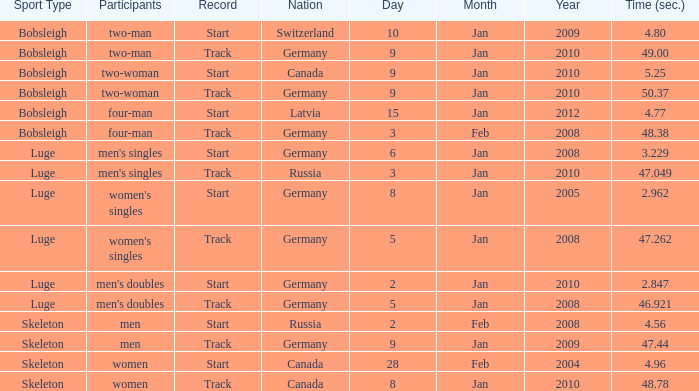Which nation had a time of 48.38? Germany. 